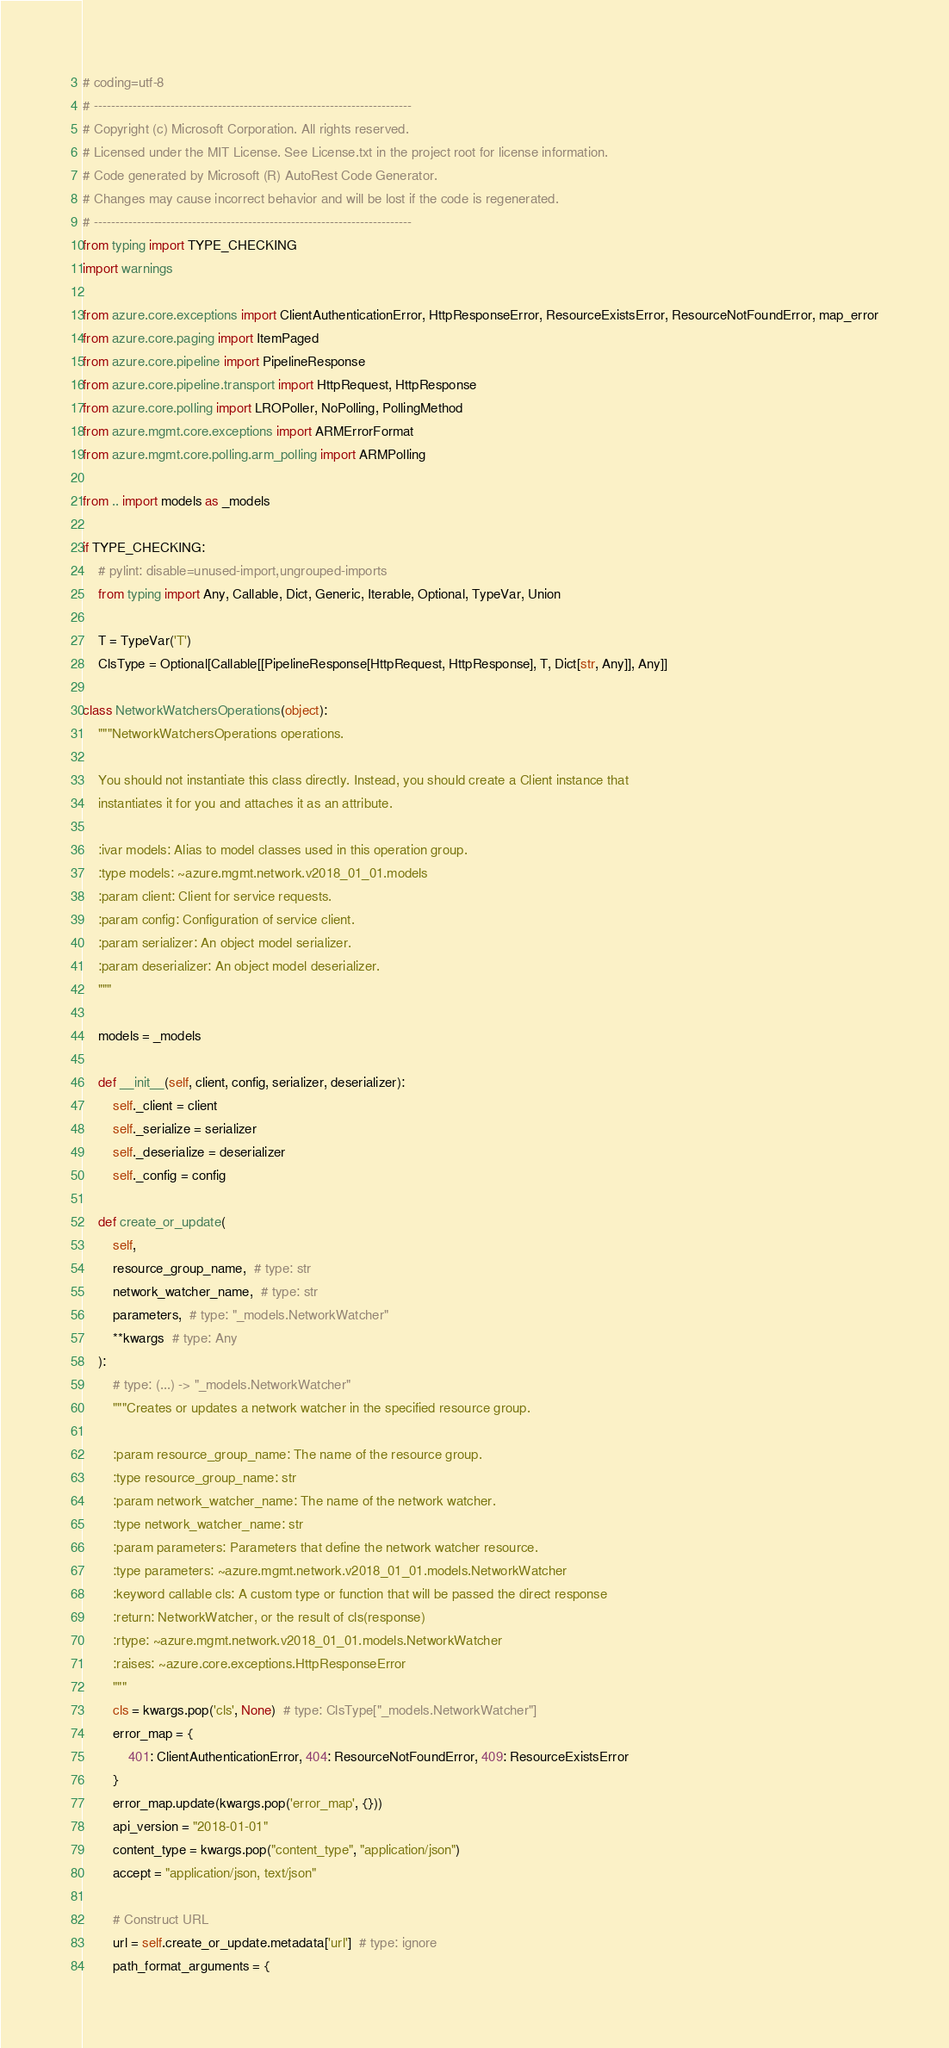Convert code to text. <code><loc_0><loc_0><loc_500><loc_500><_Python_># coding=utf-8
# --------------------------------------------------------------------------
# Copyright (c) Microsoft Corporation. All rights reserved.
# Licensed under the MIT License. See License.txt in the project root for license information.
# Code generated by Microsoft (R) AutoRest Code Generator.
# Changes may cause incorrect behavior and will be lost if the code is regenerated.
# --------------------------------------------------------------------------
from typing import TYPE_CHECKING
import warnings

from azure.core.exceptions import ClientAuthenticationError, HttpResponseError, ResourceExistsError, ResourceNotFoundError, map_error
from azure.core.paging import ItemPaged
from azure.core.pipeline import PipelineResponse
from azure.core.pipeline.transport import HttpRequest, HttpResponse
from azure.core.polling import LROPoller, NoPolling, PollingMethod
from azure.mgmt.core.exceptions import ARMErrorFormat
from azure.mgmt.core.polling.arm_polling import ARMPolling

from .. import models as _models

if TYPE_CHECKING:
    # pylint: disable=unused-import,ungrouped-imports
    from typing import Any, Callable, Dict, Generic, Iterable, Optional, TypeVar, Union

    T = TypeVar('T')
    ClsType = Optional[Callable[[PipelineResponse[HttpRequest, HttpResponse], T, Dict[str, Any]], Any]]

class NetworkWatchersOperations(object):
    """NetworkWatchersOperations operations.

    You should not instantiate this class directly. Instead, you should create a Client instance that
    instantiates it for you and attaches it as an attribute.

    :ivar models: Alias to model classes used in this operation group.
    :type models: ~azure.mgmt.network.v2018_01_01.models
    :param client: Client for service requests.
    :param config: Configuration of service client.
    :param serializer: An object model serializer.
    :param deserializer: An object model deserializer.
    """

    models = _models

    def __init__(self, client, config, serializer, deserializer):
        self._client = client
        self._serialize = serializer
        self._deserialize = deserializer
        self._config = config

    def create_or_update(
        self,
        resource_group_name,  # type: str
        network_watcher_name,  # type: str
        parameters,  # type: "_models.NetworkWatcher"
        **kwargs  # type: Any
    ):
        # type: (...) -> "_models.NetworkWatcher"
        """Creates or updates a network watcher in the specified resource group.

        :param resource_group_name: The name of the resource group.
        :type resource_group_name: str
        :param network_watcher_name: The name of the network watcher.
        :type network_watcher_name: str
        :param parameters: Parameters that define the network watcher resource.
        :type parameters: ~azure.mgmt.network.v2018_01_01.models.NetworkWatcher
        :keyword callable cls: A custom type or function that will be passed the direct response
        :return: NetworkWatcher, or the result of cls(response)
        :rtype: ~azure.mgmt.network.v2018_01_01.models.NetworkWatcher
        :raises: ~azure.core.exceptions.HttpResponseError
        """
        cls = kwargs.pop('cls', None)  # type: ClsType["_models.NetworkWatcher"]
        error_map = {
            401: ClientAuthenticationError, 404: ResourceNotFoundError, 409: ResourceExistsError
        }
        error_map.update(kwargs.pop('error_map', {}))
        api_version = "2018-01-01"
        content_type = kwargs.pop("content_type", "application/json")
        accept = "application/json, text/json"

        # Construct URL
        url = self.create_or_update.metadata['url']  # type: ignore
        path_format_arguments = {</code> 